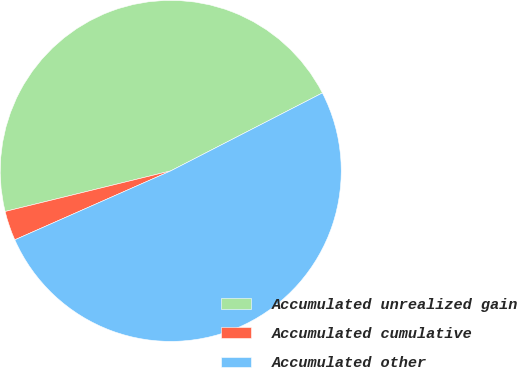<chart> <loc_0><loc_0><loc_500><loc_500><pie_chart><fcel>Accumulated unrealized gain<fcel>Accumulated cumulative<fcel>Accumulated other<nl><fcel>46.27%<fcel>2.8%<fcel>50.93%<nl></chart> 